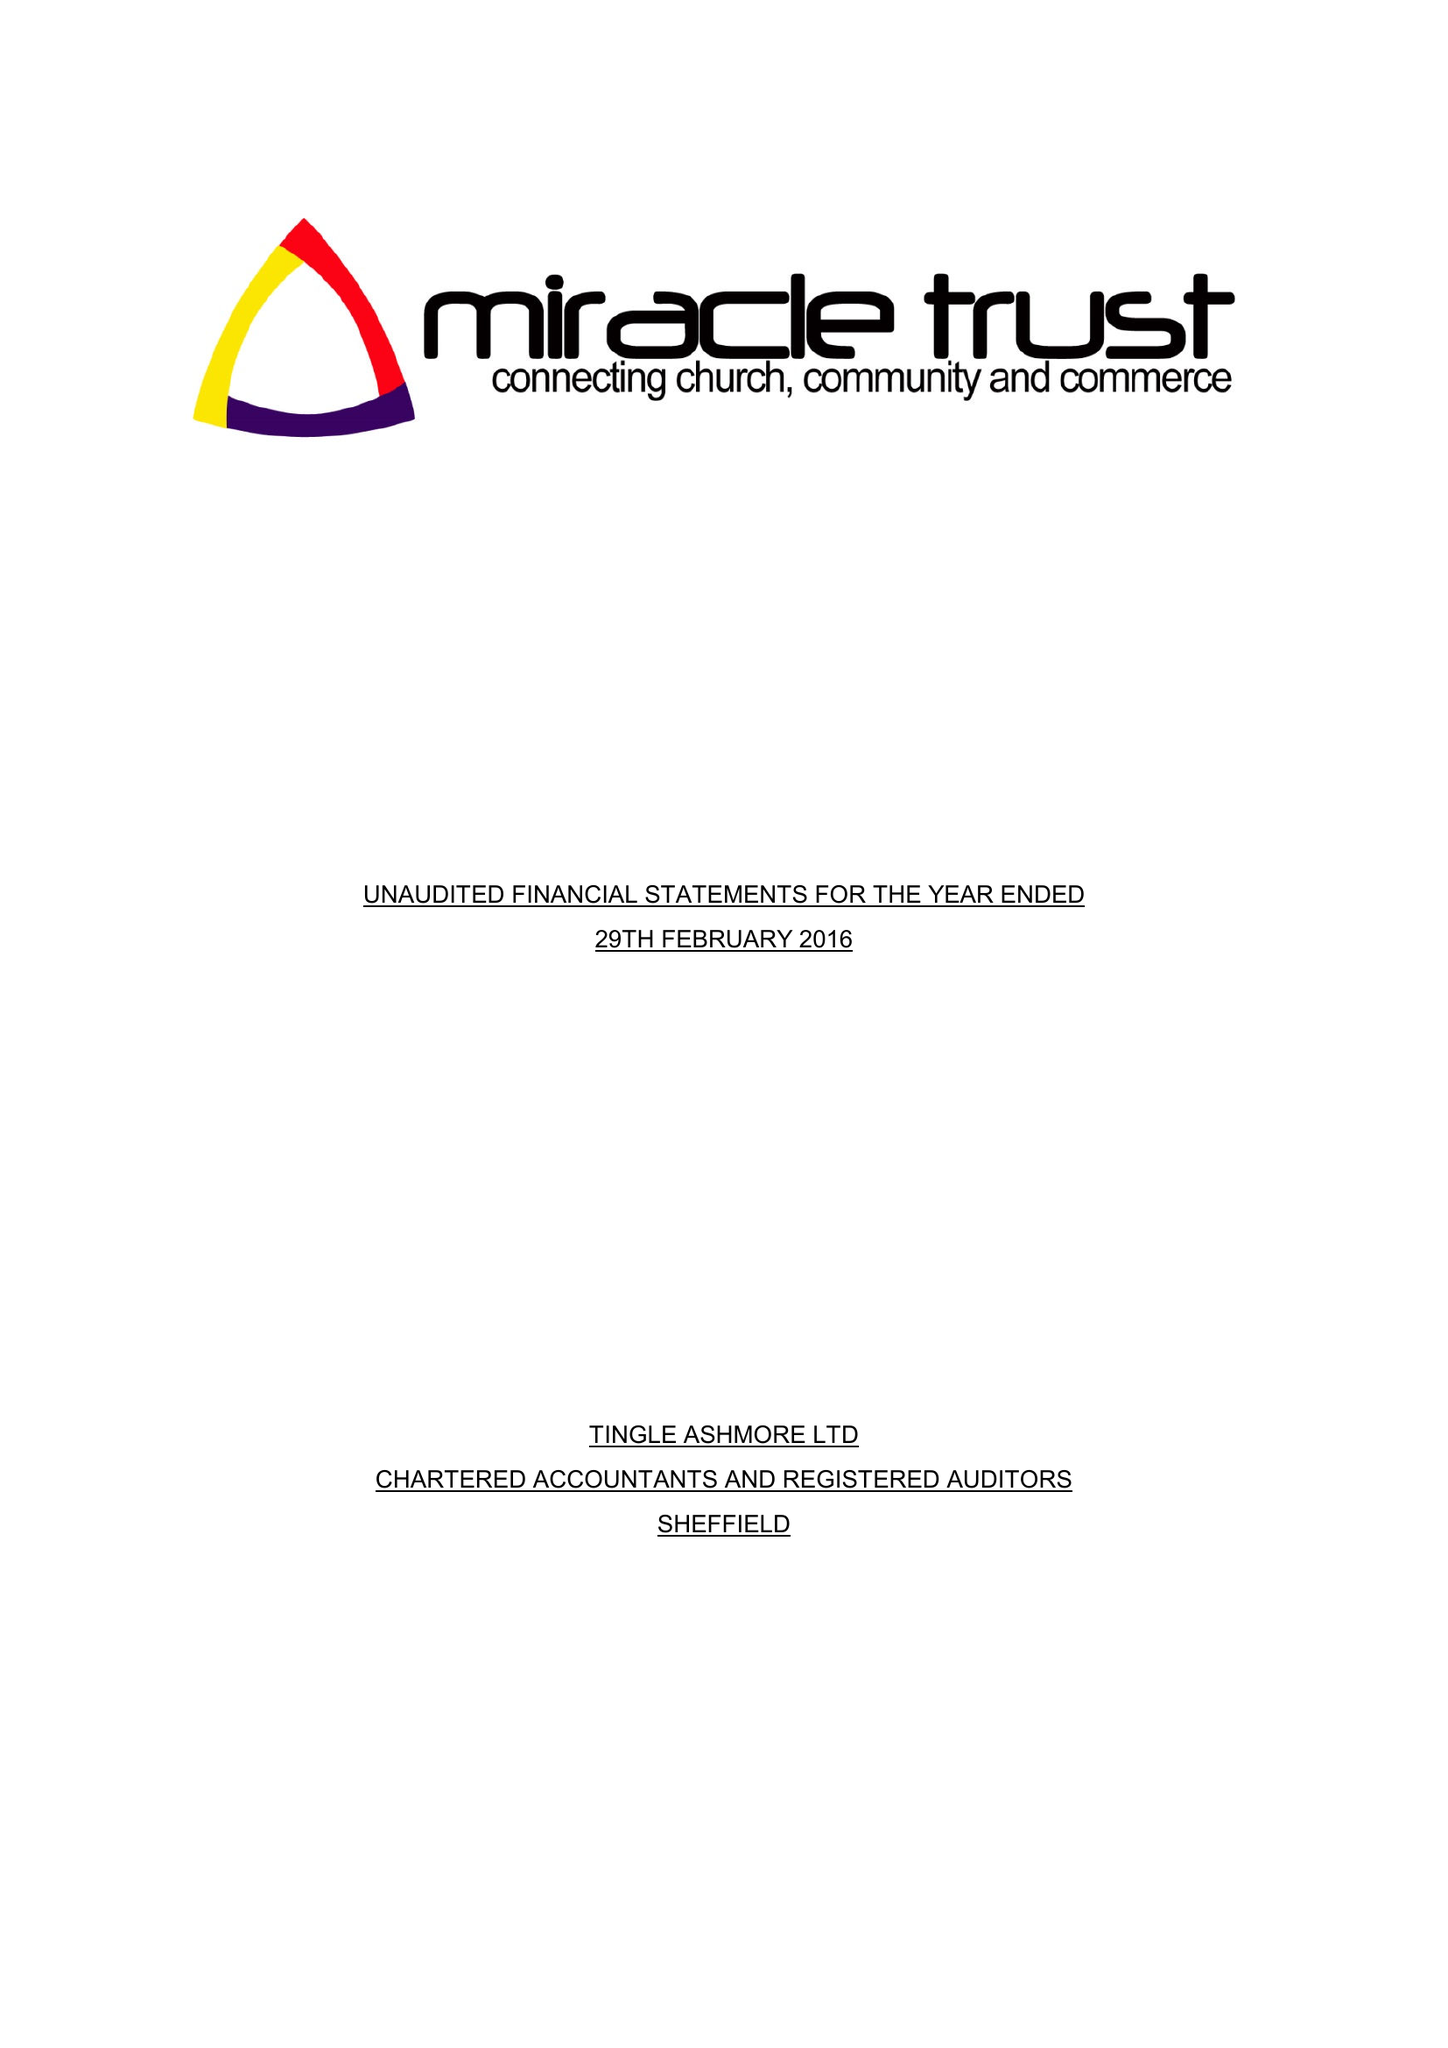What is the value for the address__street_line?
Answer the question using a single word or phrase. 61 SPRING LANE 